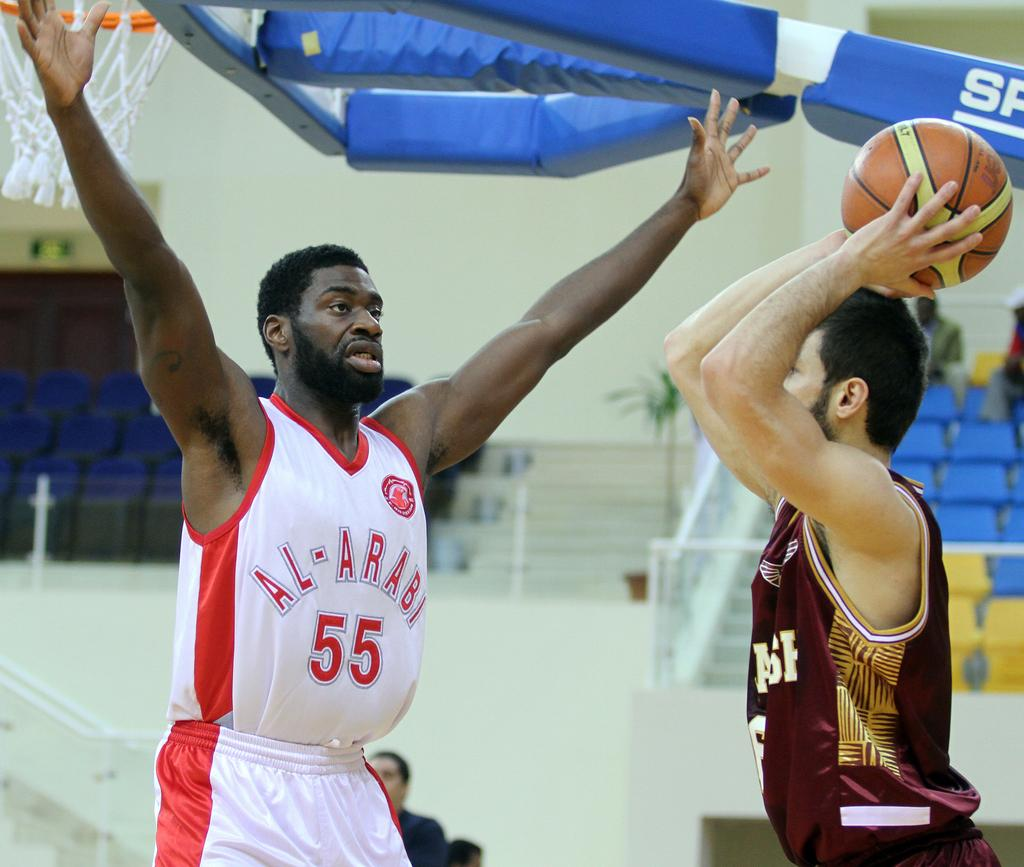<image>
Present a compact description of the photo's key features. number 55 of the white team is blocking the ball 